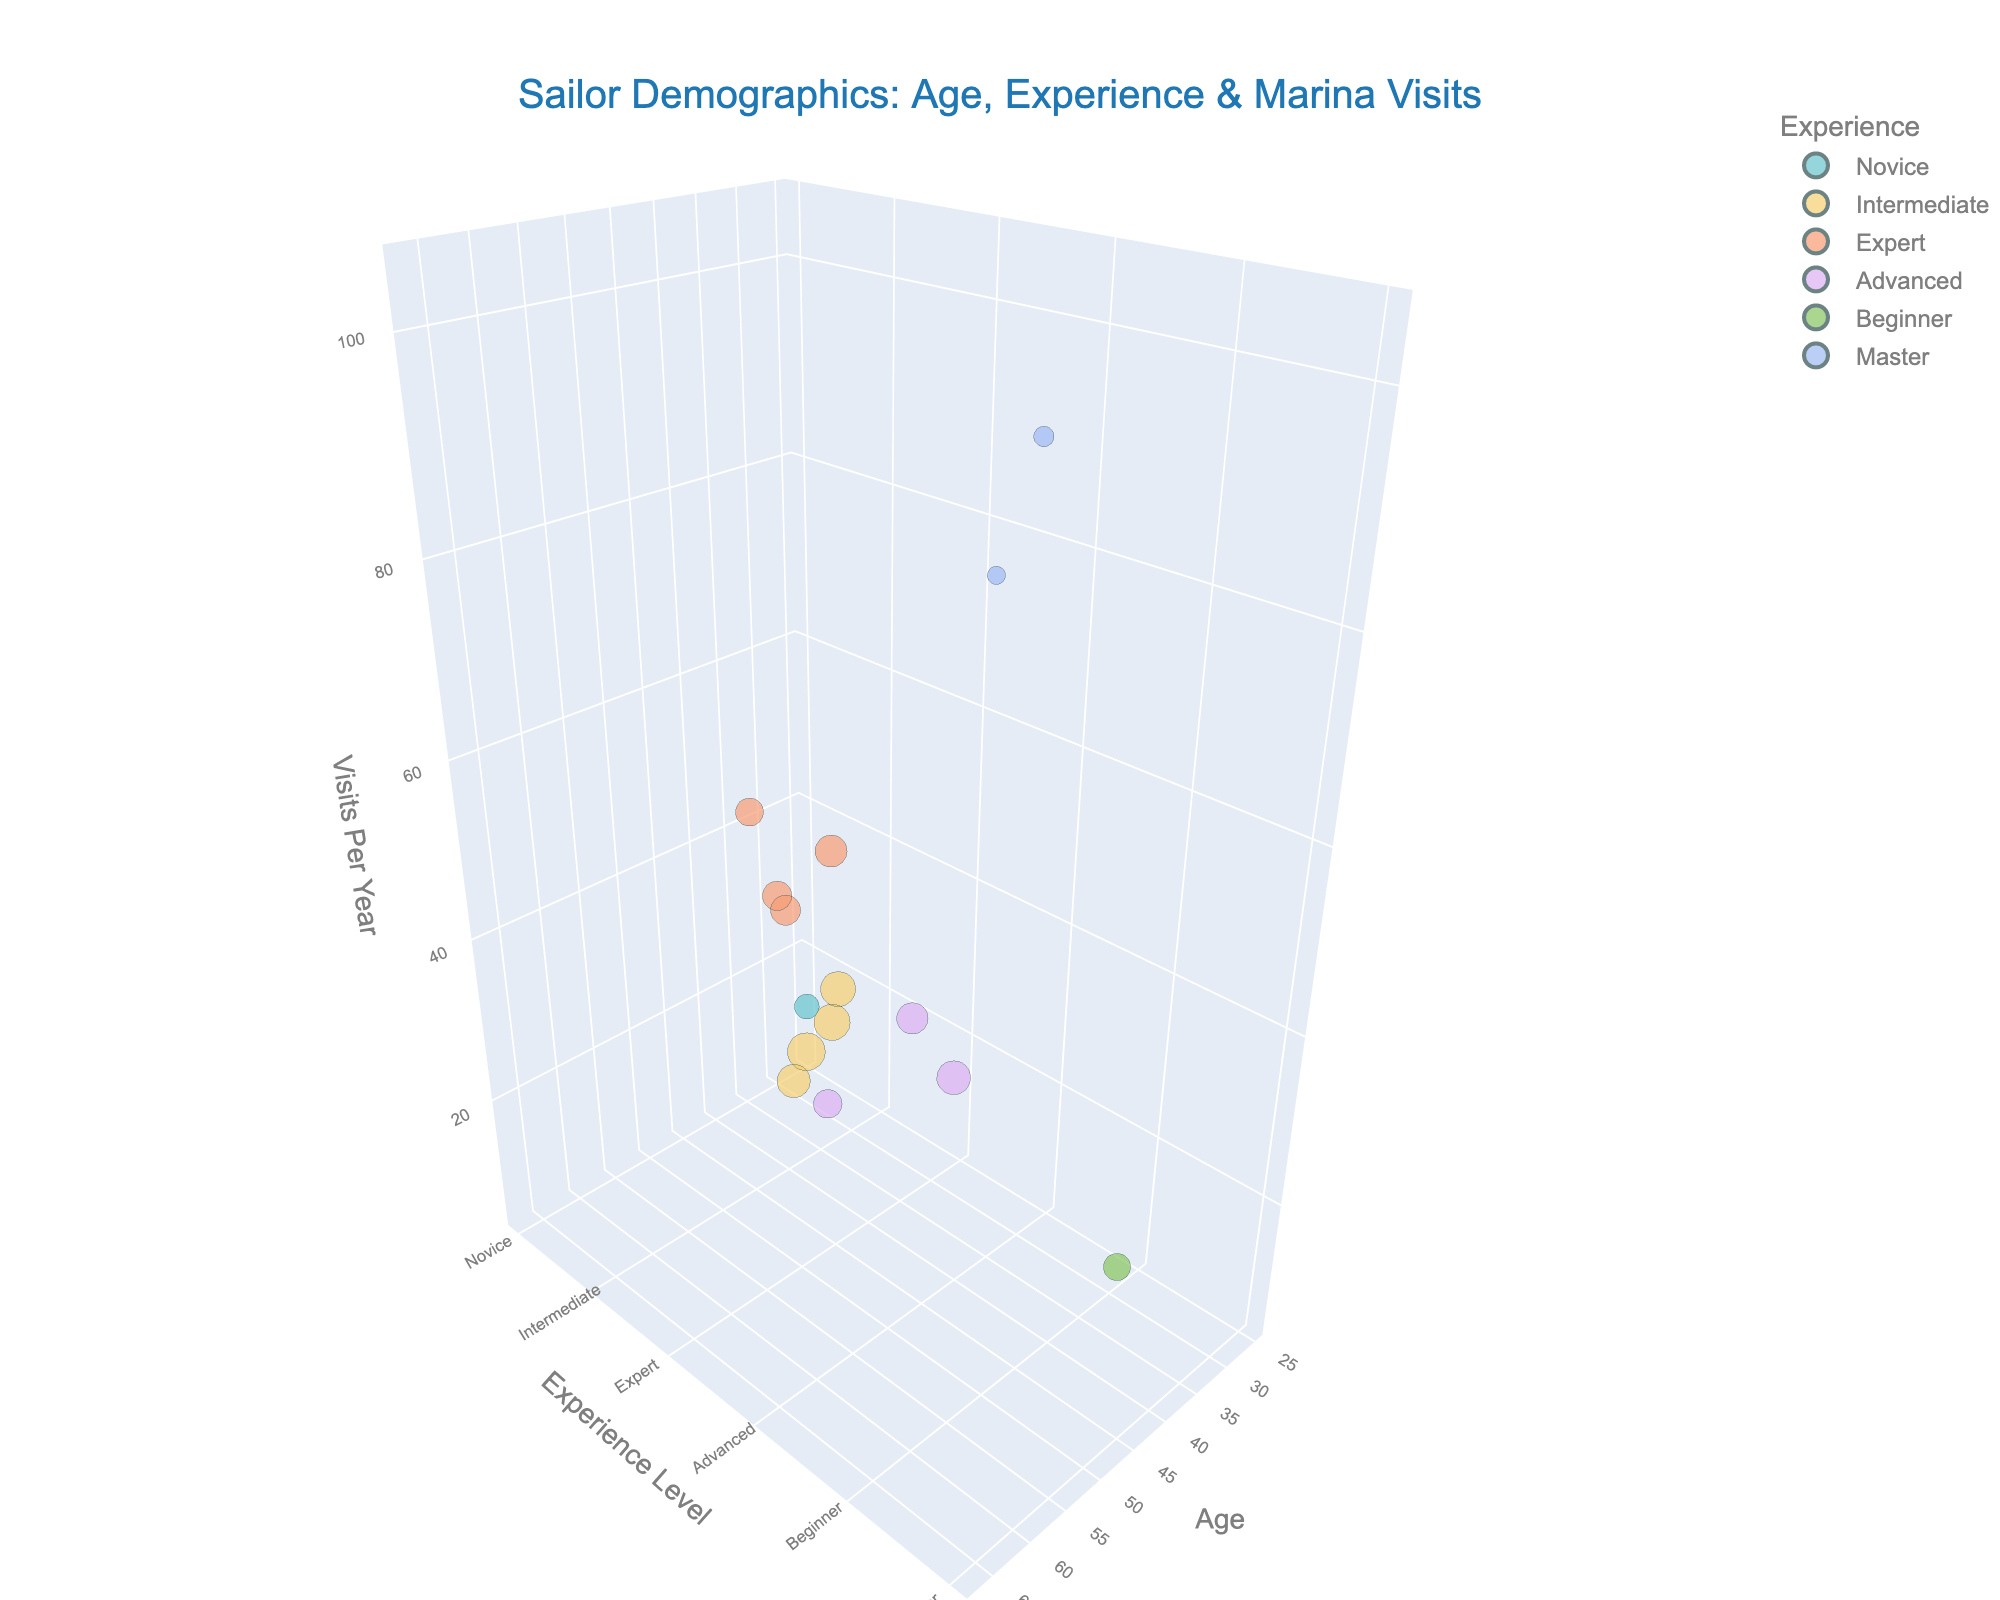What's the title of the chart? The title is displayed at the top of the chart and reads "Sailor Demographics: Age, Experience & Marina Visits".
Answer: Sailor Demographics: Age, Experience & Marina Visits What does the z-axis represent? The label on the z-axis of the chart indicates it represents 'Visits Per Year', showing how frequently sailors visit the marina each year.
Answer: Visits Per Year Which experience level has the highest number of sailors visiting 52 times per year? By looking at the 3D bubbles around the '52' mark on the z-axis and by examining their colors and hover information, we see that the bubble representing 'Expert' experience level has the number of sailors visiting 52 times per year.
Answer: Expert How many sailors with Master level experience visit the marina 104 times per year? There is a bubble near the '104' mark on the z-axis. By examining this bubble, we identify that 10 sailors with Master level experience visit the marina 104 times per year.
Answer: 10 Which age group(s) visit the marina 48 times a year, and what's their experience level? By examining the z-axis mark '48', we find bubbles representing sailors in the age groups 51, with the experience level being 'Expert'.
Answer: 51, Expert What is the combined number of sailors with Intermediate experience levels aged 32 and 33? By identifying the two corresponding bubbles on the chart, we add their sailor counts: 30 (age 32, Intermediate) + 32 (age 33, Intermediate).
Answer: 62 Which experience level has the fewest visits per year? By looking for the smallest z-values and identifying their corresponding colors and hover names, we find that sailors with 'Beginner' experience visit only 6 times per year.
Answer: Beginner What is the total number of sailors visiting the marina at least 12 times a year? By summing all sailor counts where z-values (Visits Per Year) are at least 12, we calculate: 15 (Novice) + 30 (Intermediate) + 25 (Expert) + 20 (Advanced) + 35 (Intermediate) + 22 (Expert) + 10 (Master) + 28 (Advanced) + 19 (Expert) + 32 (Intermediate) + 24 (Advanced) + 8 (Master) + 27 (Intermediate) + 21 (Expert).
Answer: 316 Who visits the marina more often: Expert sailors or Advanced sailors? By comparing the typical z-values (Visits Per Year) of bubbles associated with 'Expert' and 'Advanced' experience levels, we see that Expert sailors generally have higher z-values (e.g., 52, 48, 60) compared to Advanced sailors (e.g., 36, 30, 40).
Answer: Expert sailors 